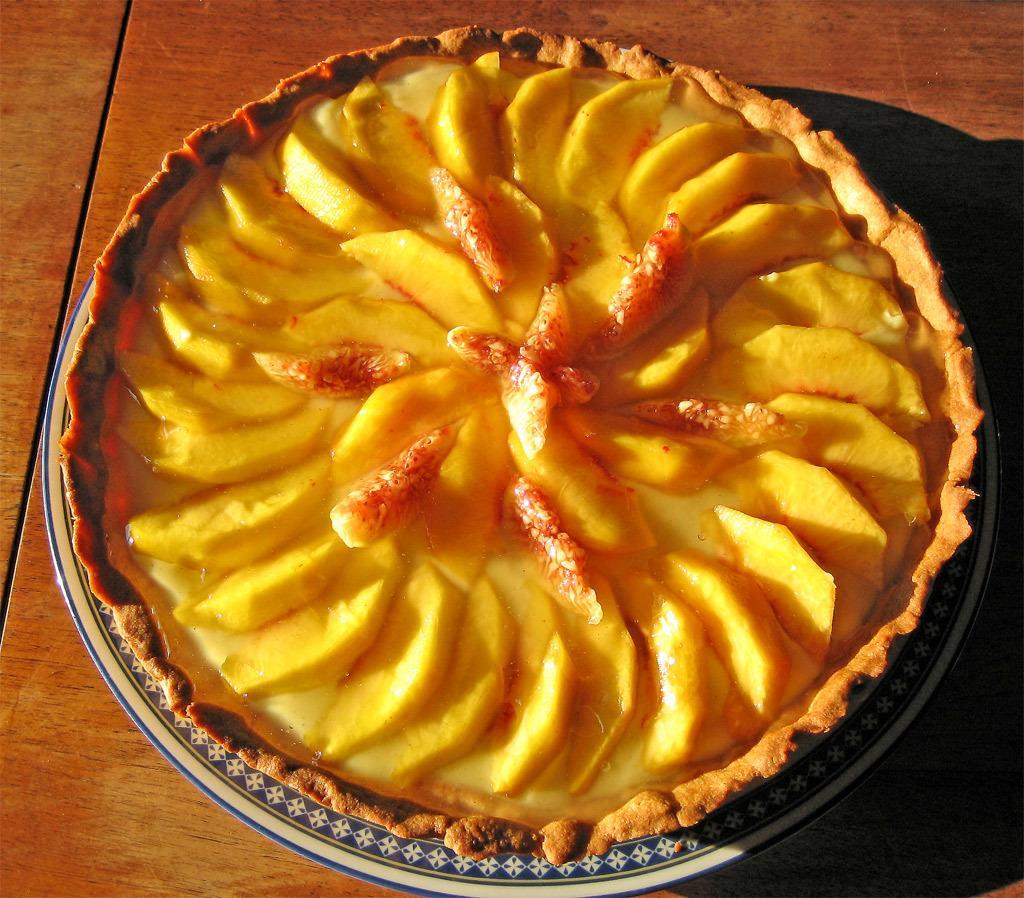Please provide a concise description of this image. In this image we can see the food item on a plate and the plate placed on the table. 